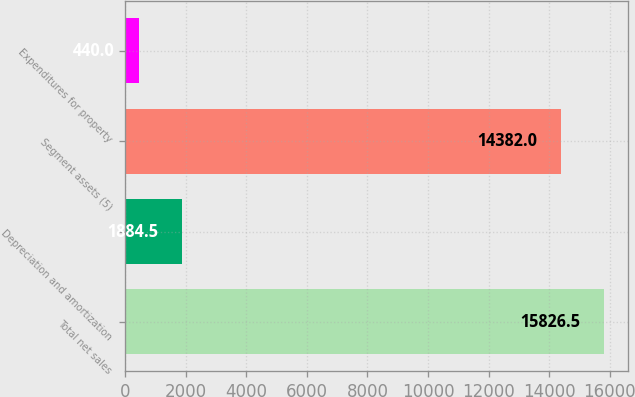<chart> <loc_0><loc_0><loc_500><loc_500><bar_chart><fcel>Total net sales<fcel>Depreciation and amortization<fcel>Segment assets (5)<fcel>Expenditures for property<nl><fcel>15826.5<fcel>1884.5<fcel>14382<fcel>440<nl></chart> 